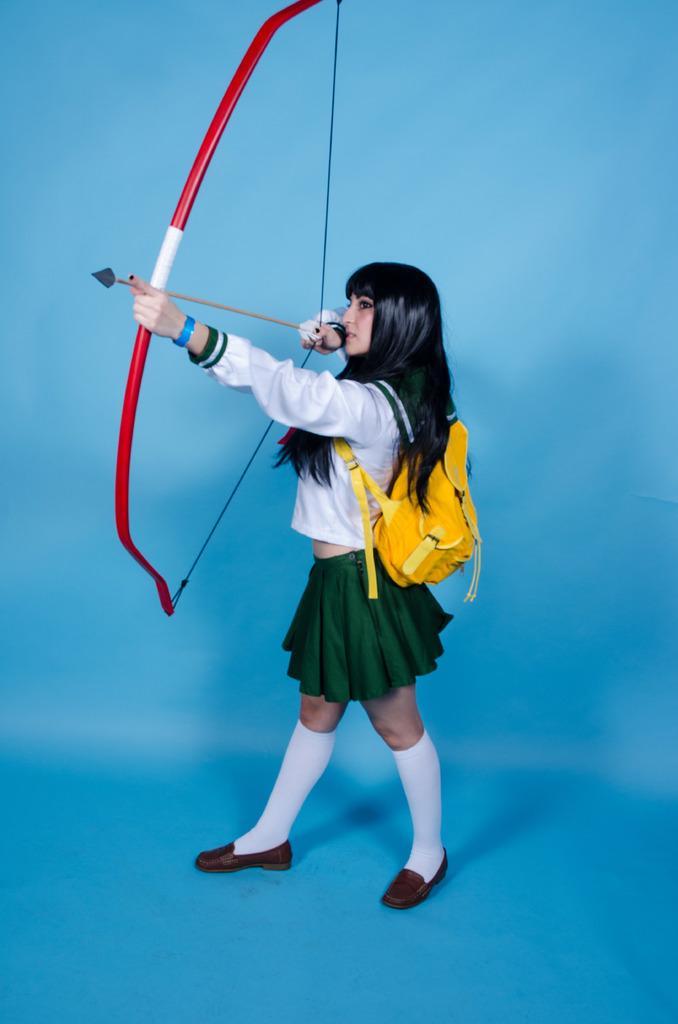Can you describe this image briefly? In this picture there is a woman wearing a bag and holding bow and arrow. The picture has blue surface and background. 